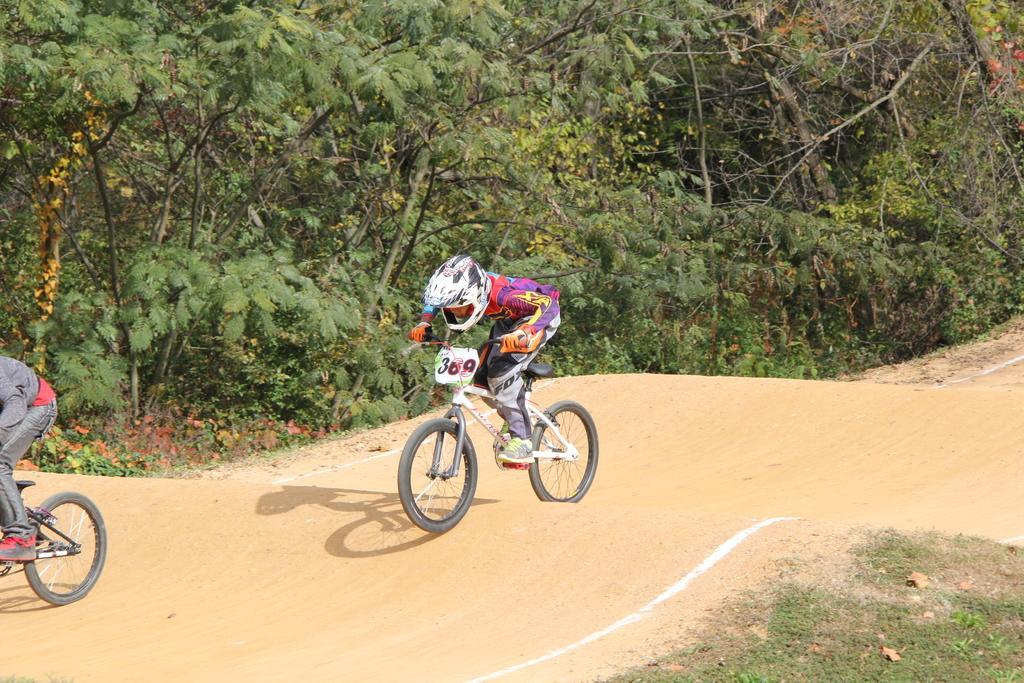In one or two sentences, can you explain what this image depicts? This picture shows couple of them riding bicycles and and we see trees. One of them wore helmet on the head and gloves to his hands. 